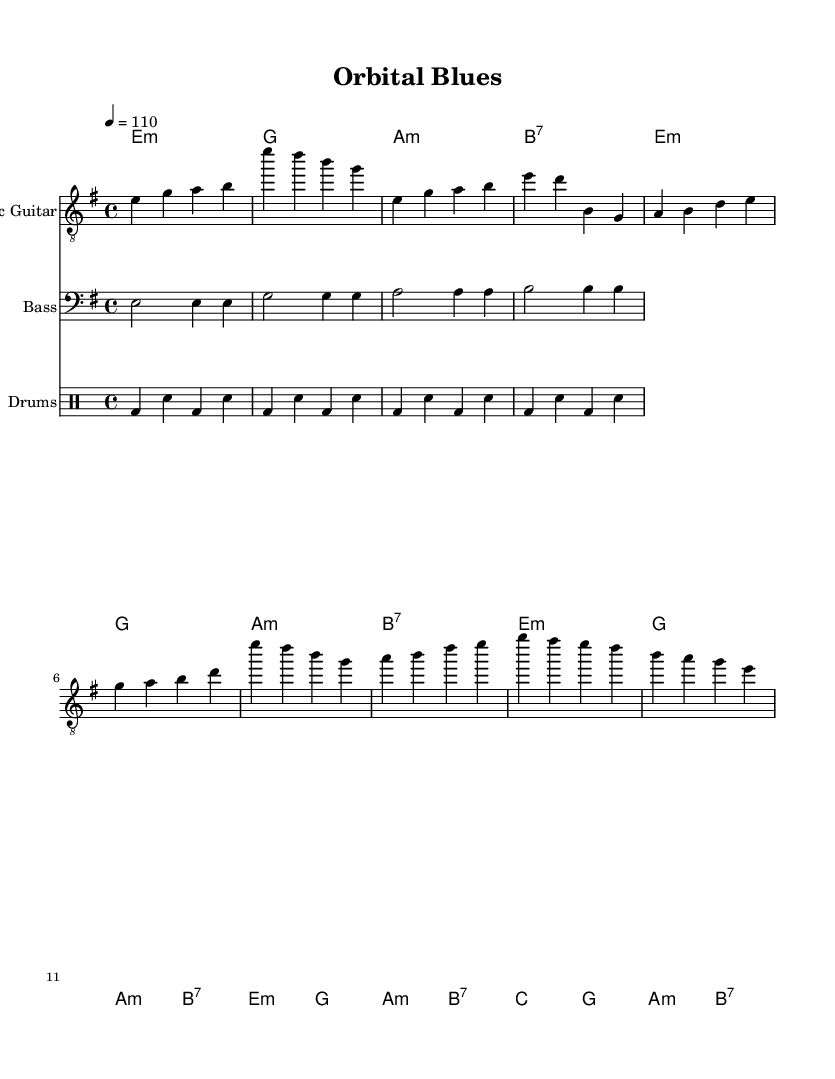What is the key signature of this music? The key signature is E minor, which has one sharp note (F#). It is indicated at the beginning of the staff, showing the sharp in the key.
Answer: E minor What is the time signature of this music? The time signature is 4/4, which indicates that there are four beats in each measure and the quarter note receives one beat. It is displayed at the beginning of the staff.
Answer: 4/4 What is the tempo marking of this piece? The tempo marking indicates a speed of 110 beats per minute, as represented by the notation "4 = 110" at the beginning of the music. This expresses the tempo in beats per minute.
Answer: 110 How many measures are there in the chorus section? To find the number of measures in the chorus, we count the measures written under the chorus part from the sheet music notation. The chorus has 8 measures in total.
Answer: 8 What is the primary chord used in the verse? The primary chord in the verse is E minor, as it is the first chord indicated in the chord progressions of the verse section. The chord appears at the start and is repeated multiple times.
Answer: E minor Which instrument is featured in the melody section? The instrument featured in the melody section is the Electric Guitar, as indicated by the label for the staff that specifically notes "Electric Guitar." This is where the main melodic line is written.
Answer: Electric Guitar In the bass line pattern, what note is played starting the pattern? The bass line pattern starts with the note E, which is indicated at the beginning of the bass staff as the first note of the first measure. This is the fundamental note of the bass pattern.
Answer: E 